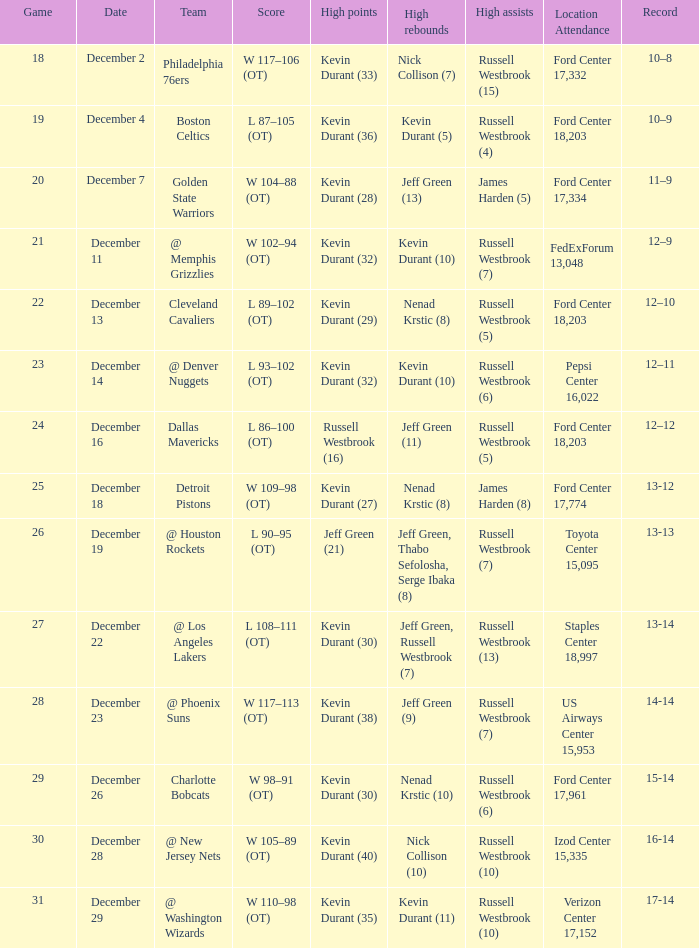Who holds peak scores when the verizon center, having a 17,152-person capacity, serves as the location for attendance? Kevin Durant (35). 